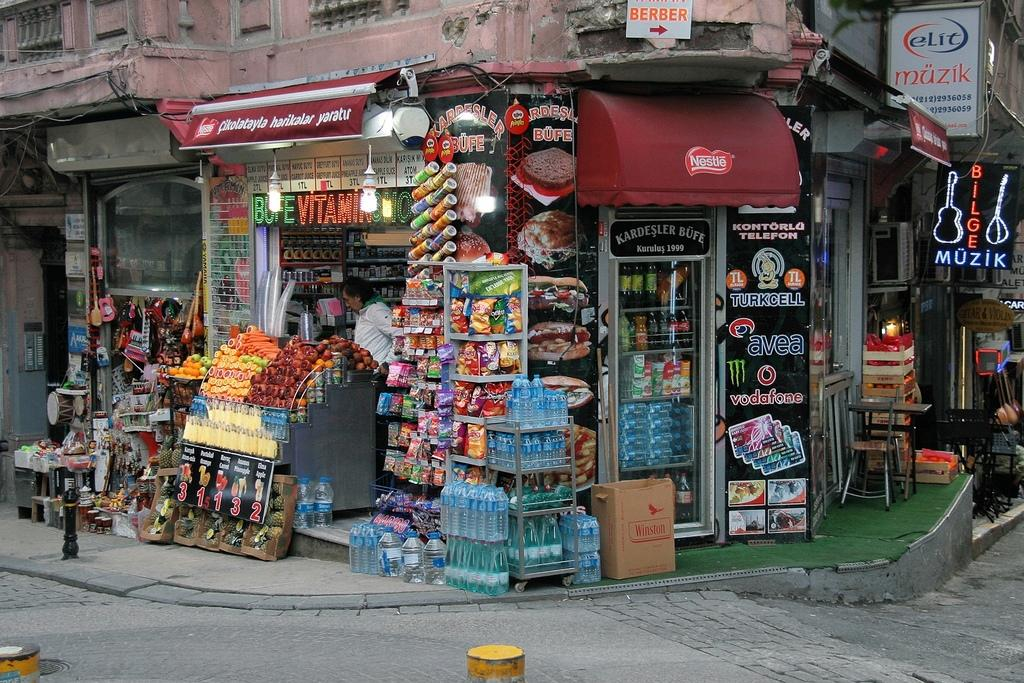Provide a one-sentence caption for the provided image. The store front has signs for Nestle, Pringles, and Vodafone. 